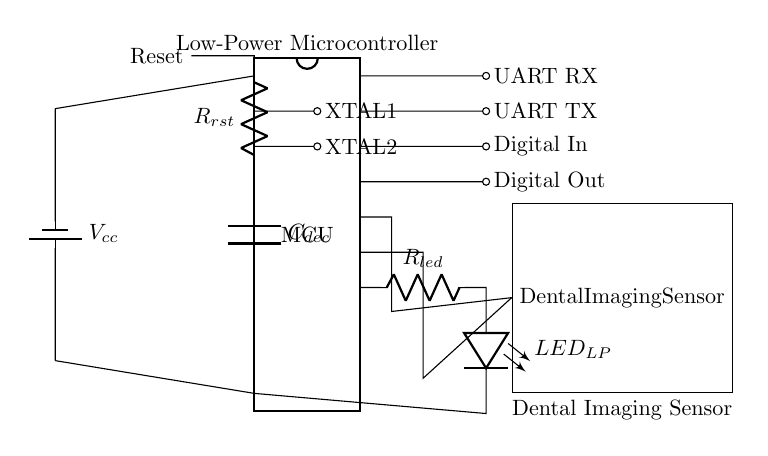What is the type of microcontroller used in this circuit? The circuit diagram indicates that a low-power microcontroller (MCU) is utilized, as denoted by the "MCU" label in the diagram.
Answer: low-power microcontroller How many pins does the microcontroller have? The microcontroller is shown as a DIP chip with 20 pins, as indicated by the "num pins=20" specification in the draw command.
Answer: 20 pins What is the purpose of the crystal oscillator in this circuit? The crystal oscillator is connected to pins 2 and 3 of the microcontroller and is essential for providing a stable clock signal, which is crucial for the timing of the microcontroller operations.
Answer: clock signal Which component is connected to pin 15 of the microcontroller? Pin 15 of the microcontroller is connected to the dental imaging sensor, which is represented as a rectangular block labeled "Dental Imaging Sensor" in the circuit.
Answer: dental imaging sensor What type of connections are present at pins 19 and 20? Pins 19 and 20 are designated for UART communication, specifically for UART TX (transmit) and UART RX (receive) connections facilitate serial data communication.
Answer: UART TX and RX What component limits the current to the low-power LED? The resistor labeled "R_led" in the circuit diagram is connected in series with the low-power LED (LED_LP) to limit the current flowing through it, ensuring safe operation.
Answer: R_led Explain the function of the decoupling capacitor. The decoupling capacitor, labeled "C_dec", is connected between the power supply pins of the microcontroller. Its main function is to filter out noise and stabilize the supply voltage, ensuring that the microcontroller operates reliably even with load variations.
Answer: filter noise and stabilize voltage 